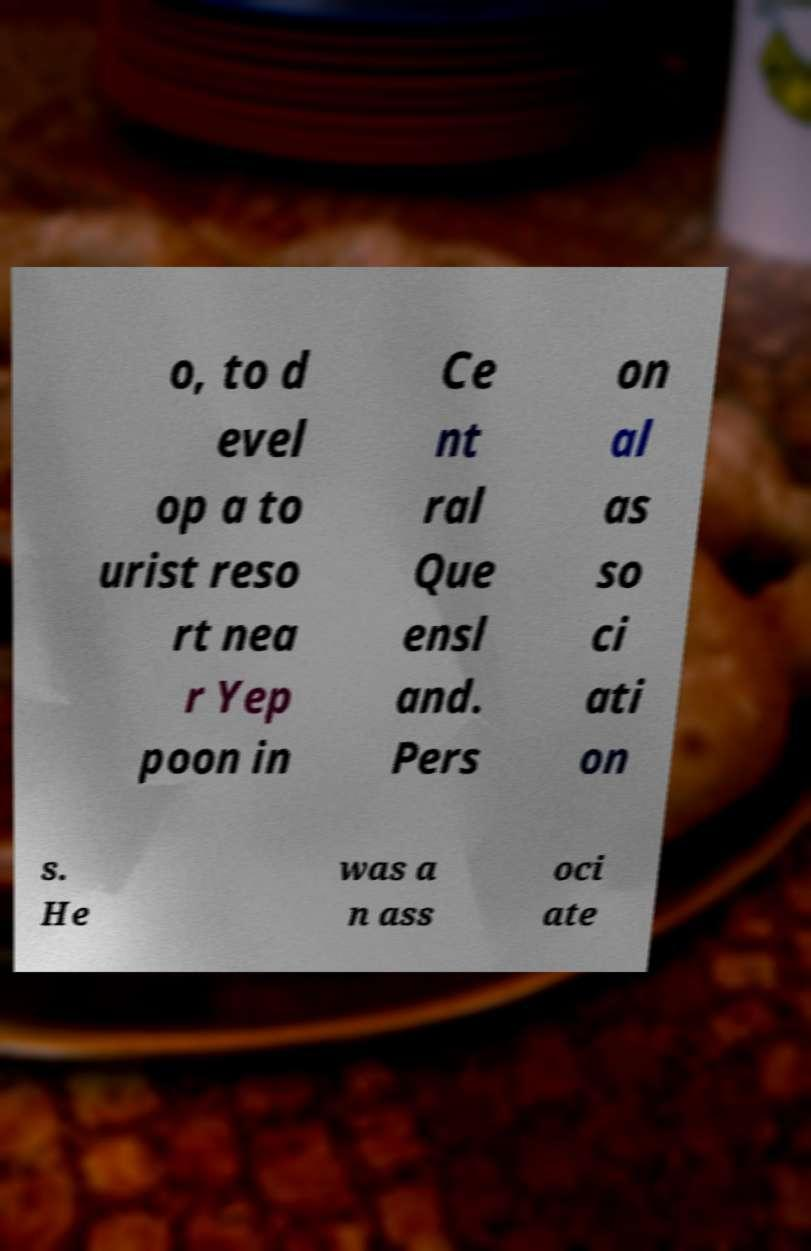I need the written content from this picture converted into text. Can you do that? o, to d evel op a to urist reso rt nea r Yep poon in Ce nt ral Que ensl and. Pers on al as so ci ati on s. He was a n ass oci ate 